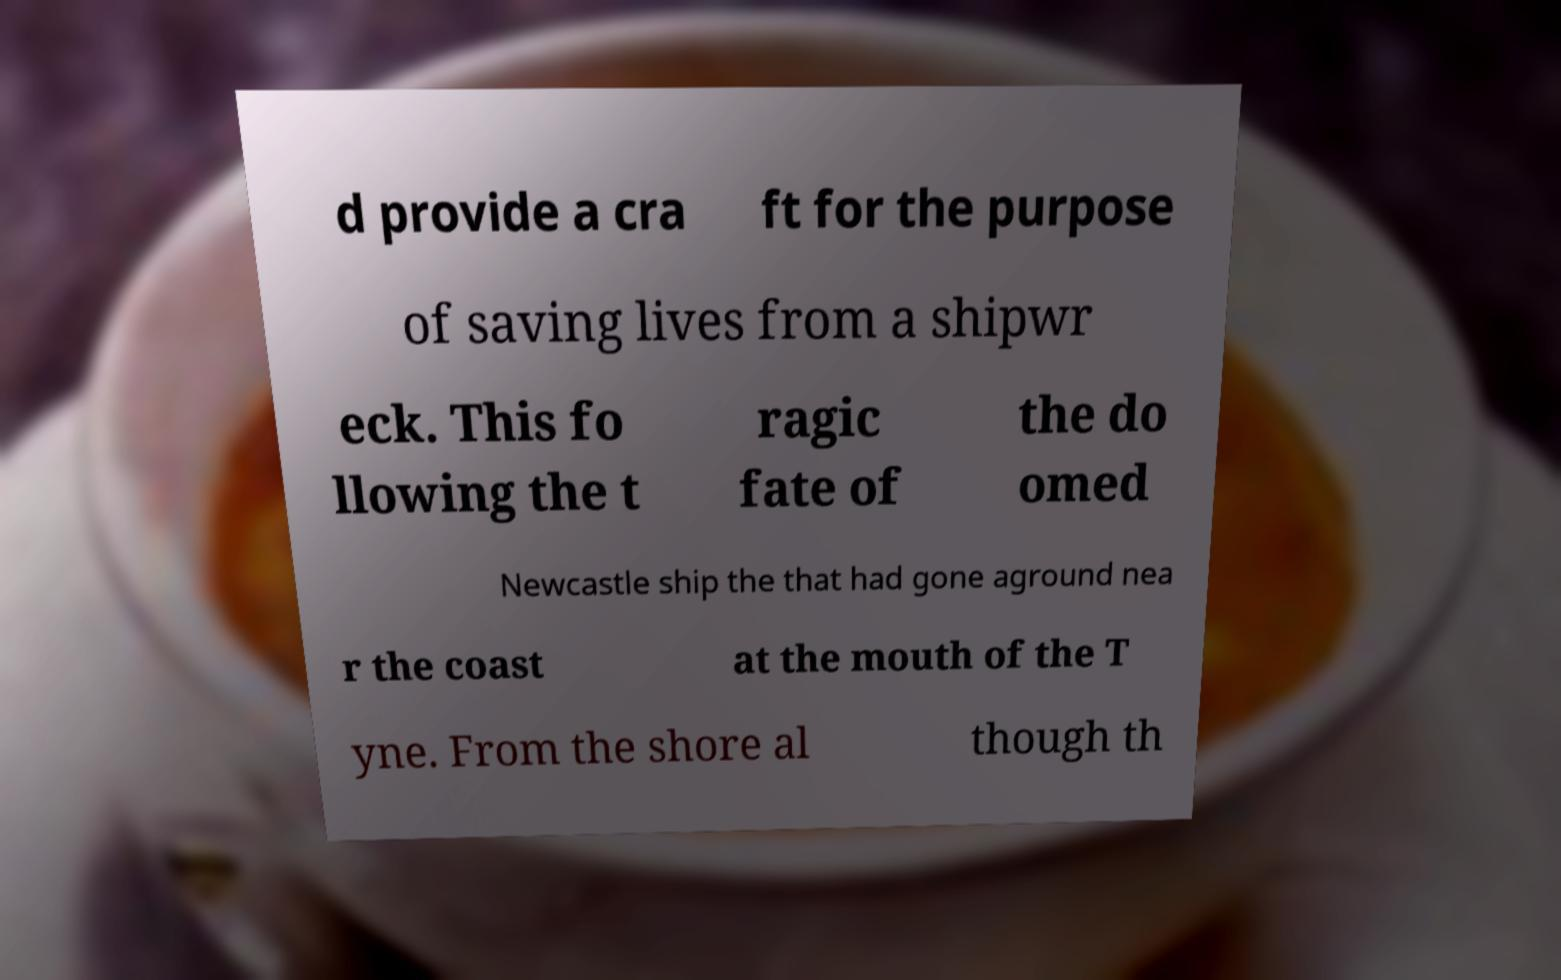Can you accurately transcribe the text from the provided image for me? d provide a cra ft for the purpose of saving lives from a shipwr eck. This fo llowing the t ragic fate of the do omed Newcastle ship the that had gone aground nea r the coast at the mouth of the T yne. From the shore al though th 